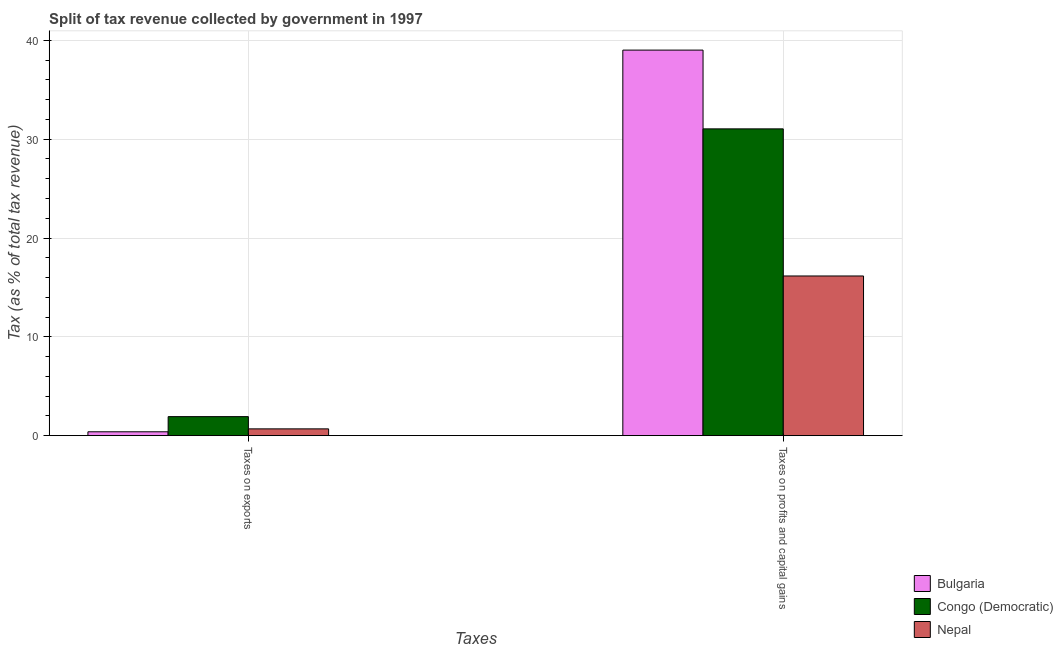What is the label of the 1st group of bars from the left?
Your answer should be compact. Taxes on exports. What is the percentage of revenue obtained from taxes on exports in Bulgaria?
Your answer should be very brief. 0.39. Across all countries, what is the maximum percentage of revenue obtained from taxes on exports?
Ensure brevity in your answer.  1.92. Across all countries, what is the minimum percentage of revenue obtained from taxes on exports?
Keep it short and to the point. 0.39. In which country was the percentage of revenue obtained from taxes on profits and capital gains minimum?
Give a very brief answer. Nepal. What is the total percentage of revenue obtained from taxes on profits and capital gains in the graph?
Provide a short and direct response. 86.22. What is the difference between the percentage of revenue obtained from taxes on exports in Bulgaria and that in Congo (Democratic)?
Provide a succinct answer. -1.53. What is the difference between the percentage of revenue obtained from taxes on exports in Nepal and the percentage of revenue obtained from taxes on profits and capital gains in Bulgaria?
Ensure brevity in your answer.  -38.33. What is the average percentage of revenue obtained from taxes on profits and capital gains per country?
Provide a succinct answer. 28.74. What is the difference between the percentage of revenue obtained from taxes on exports and percentage of revenue obtained from taxes on profits and capital gains in Bulgaria?
Your answer should be compact. -38.63. In how many countries, is the percentage of revenue obtained from taxes on exports greater than 14 %?
Provide a short and direct response. 0. What is the ratio of the percentage of revenue obtained from taxes on exports in Congo (Democratic) to that in Nepal?
Keep it short and to the point. 2.8. In how many countries, is the percentage of revenue obtained from taxes on profits and capital gains greater than the average percentage of revenue obtained from taxes on profits and capital gains taken over all countries?
Your answer should be very brief. 2. What does the 2nd bar from the left in Taxes on profits and capital gains represents?
Your answer should be very brief. Congo (Democratic). What does the 2nd bar from the right in Taxes on exports represents?
Your response must be concise. Congo (Democratic). Are all the bars in the graph horizontal?
Your answer should be compact. No. How many countries are there in the graph?
Keep it short and to the point. 3. Does the graph contain any zero values?
Your response must be concise. No. What is the title of the graph?
Provide a short and direct response. Split of tax revenue collected by government in 1997. What is the label or title of the X-axis?
Ensure brevity in your answer.  Taxes. What is the label or title of the Y-axis?
Give a very brief answer. Tax (as % of total tax revenue). What is the Tax (as % of total tax revenue) in Bulgaria in Taxes on exports?
Provide a short and direct response. 0.39. What is the Tax (as % of total tax revenue) of Congo (Democratic) in Taxes on exports?
Offer a very short reply. 1.92. What is the Tax (as % of total tax revenue) in Nepal in Taxes on exports?
Your response must be concise. 0.69. What is the Tax (as % of total tax revenue) in Bulgaria in Taxes on profits and capital gains?
Provide a short and direct response. 39.02. What is the Tax (as % of total tax revenue) of Congo (Democratic) in Taxes on profits and capital gains?
Provide a short and direct response. 31.05. What is the Tax (as % of total tax revenue) in Nepal in Taxes on profits and capital gains?
Your answer should be very brief. 16.16. Across all Taxes, what is the maximum Tax (as % of total tax revenue) in Bulgaria?
Provide a succinct answer. 39.02. Across all Taxes, what is the maximum Tax (as % of total tax revenue) in Congo (Democratic)?
Your answer should be compact. 31.05. Across all Taxes, what is the maximum Tax (as % of total tax revenue) in Nepal?
Provide a succinct answer. 16.16. Across all Taxes, what is the minimum Tax (as % of total tax revenue) in Bulgaria?
Offer a very short reply. 0.39. Across all Taxes, what is the minimum Tax (as % of total tax revenue) of Congo (Democratic)?
Make the answer very short. 1.92. Across all Taxes, what is the minimum Tax (as % of total tax revenue) in Nepal?
Your answer should be compact. 0.69. What is the total Tax (as % of total tax revenue) of Bulgaria in the graph?
Offer a very short reply. 39.41. What is the total Tax (as % of total tax revenue) in Congo (Democratic) in the graph?
Offer a very short reply. 32.97. What is the total Tax (as % of total tax revenue) of Nepal in the graph?
Make the answer very short. 16.84. What is the difference between the Tax (as % of total tax revenue) in Bulgaria in Taxes on exports and that in Taxes on profits and capital gains?
Your response must be concise. -38.63. What is the difference between the Tax (as % of total tax revenue) in Congo (Democratic) in Taxes on exports and that in Taxes on profits and capital gains?
Make the answer very short. -29.12. What is the difference between the Tax (as % of total tax revenue) in Nepal in Taxes on exports and that in Taxes on profits and capital gains?
Offer a very short reply. -15.47. What is the difference between the Tax (as % of total tax revenue) of Bulgaria in Taxes on exports and the Tax (as % of total tax revenue) of Congo (Democratic) in Taxes on profits and capital gains?
Your answer should be very brief. -30.66. What is the difference between the Tax (as % of total tax revenue) in Bulgaria in Taxes on exports and the Tax (as % of total tax revenue) in Nepal in Taxes on profits and capital gains?
Ensure brevity in your answer.  -15.77. What is the difference between the Tax (as % of total tax revenue) in Congo (Democratic) in Taxes on exports and the Tax (as % of total tax revenue) in Nepal in Taxes on profits and capital gains?
Offer a terse response. -14.23. What is the average Tax (as % of total tax revenue) of Bulgaria per Taxes?
Provide a short and direct response. 19.7. What is the average Tax (as % of total tax revenue) of Congo (Democratic) per Taxes?
Give a very brief answer. 16.48. What is the average Tax (as % of total tax revenue) of Nepal per Taxes?
Your answer should be compact. 8.42. What is the difference between the Tax (as % of total tax revenue) in Bulgaria and Tax (as % of total tax revenue) in Congo (Democratic) in Taxes on exports?
Make the answer very short. -1.53. What is the difference between the Tax (as % of total tax revenue) of Bulgaria and Tax (as % of total tax revenue) of Nepal in Taxes on exports?
Give a very brief answer. -0.3. What is the difference between the Tax (as % of total tax revenue) of Congo (Democratic) and Tax (as % of total tax revenue) of Nepal in Taxes on exports?
Make the answer very short. 1.24. What is the difference between the Tax (as % of total tax revenue) in Bulgaria and Tax (as % of total tax revenue) in Congo (Democratic) in Taxes on profits and capital gains?
Give a very brief answer. 7.97. What is the difference between the Tax (as % of total tax revenue) in Bulgaria and Tax (as % of total tax revenue) in Nepal in Taxes on profits and capital gains?
Make the answer very short. 22.86. What is the difference between the Tax (as % of total tax revenue) of Congo (Democratic) and Tax (as % of total tax revenue) of Nepal in Taxes on profits and capital gains?
Your answer should be compact. 14.89. What is the ratio of the Tax (as % of total tax revenue) of Congo (Democratic) in Taxes on exports to that in Taxes on profits and capital gains?
Your response must be concise. 0.06. What is the ratio of the Tax (as % of total tax revenue) in Nepal in Taxes on exports to that in Taxes on profits and capital gains?
Your answer should be compact. 0.04. What is the difference between the highest and the second highest Tax (as % of total tax revenue) in Bulgaria?
Keep it short and to the point. 38.63. What is the difference between the highest and the second highest Tax (as % of total tax revenue) in Congo (Democratic)?
Give a very brief answer. 29.12. What is the difference between the highest and the second highest Tax (as % of total tax revenue) in Nepal?
Give a very brief answer. 15.47. What is the difference between the highest and the lowest Tax (as % of total tax revenue) of Bulgaria?
Make the answer very short. 38.63. What is the difference between the highest and the lowest Tax (as % of total tax revenue) in Congo (Democratic)?
Make the answer very short. 29.12. What is the difference between the highest and the lowest Tax (as % of total tax revenue) in Nepal?
Ensure brevity in your answer.  15.47. 